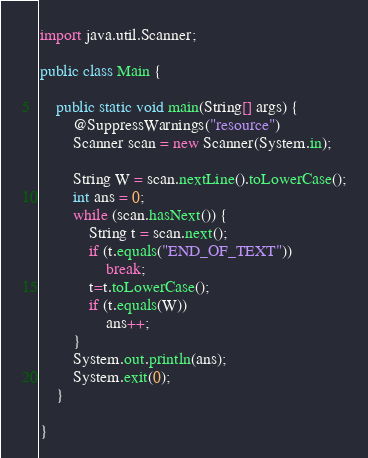<code> <loc_0><loc_0><loc_500><loc_500><_Java_>import java.util.Scanner;

public class Main {

	public static void main(String[] args) {
		@SuppressWarnings("resource")
		Scanner scan = new Scanner(System.in);

		String W = scan.nextLine().toLowerCase();
		int ans = 0;
		while (scan.hasNext()) {
			String t = scan.next();
			if (t.equals("END_OF_TEXT"))
				break;
			t=t.toLowerCase();
			if (t.equals(W))
				ans++;
		}
		System.out.println(ans);
		System.exit(0);
	}

}</code> 